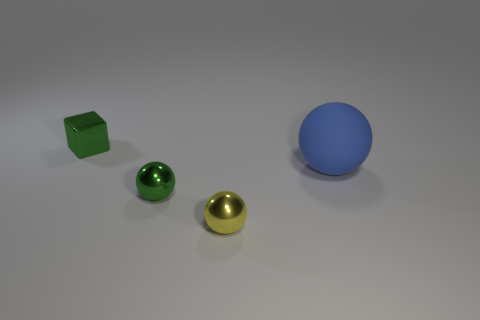The yellow object that is made of the same material as the small green cube is what shape? sphere 